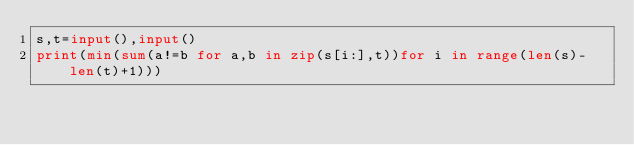Convert code to text. <code><loc_0><loc_0><loc_500><loc_500><_Python_>s,t=input(),input()
print(min(sum(a!=b for a,b in zip(s[i:],t))for i in range(len(s)-len(t)+1)))</code> 